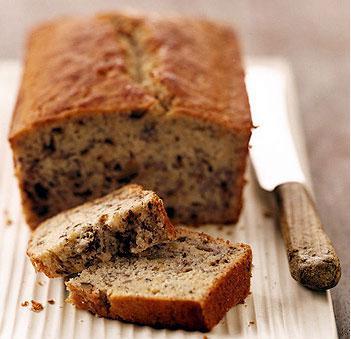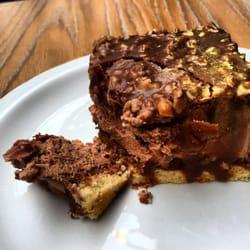The first image is the image on the left, the second image is the image on the right. Examine the images to the left and right. Is the description "Loaves of bakery items are sitting in white rectangular containers in the image on the left." accurate? Answer yes or no. No. The first image is the image on the left, the second image is the image on the right. For the images displayed, is the sentence "An image shows multiple baked treats of the same type, packaged in open-top white rectangular boxes." factually correct? Answer yes or no. No. 